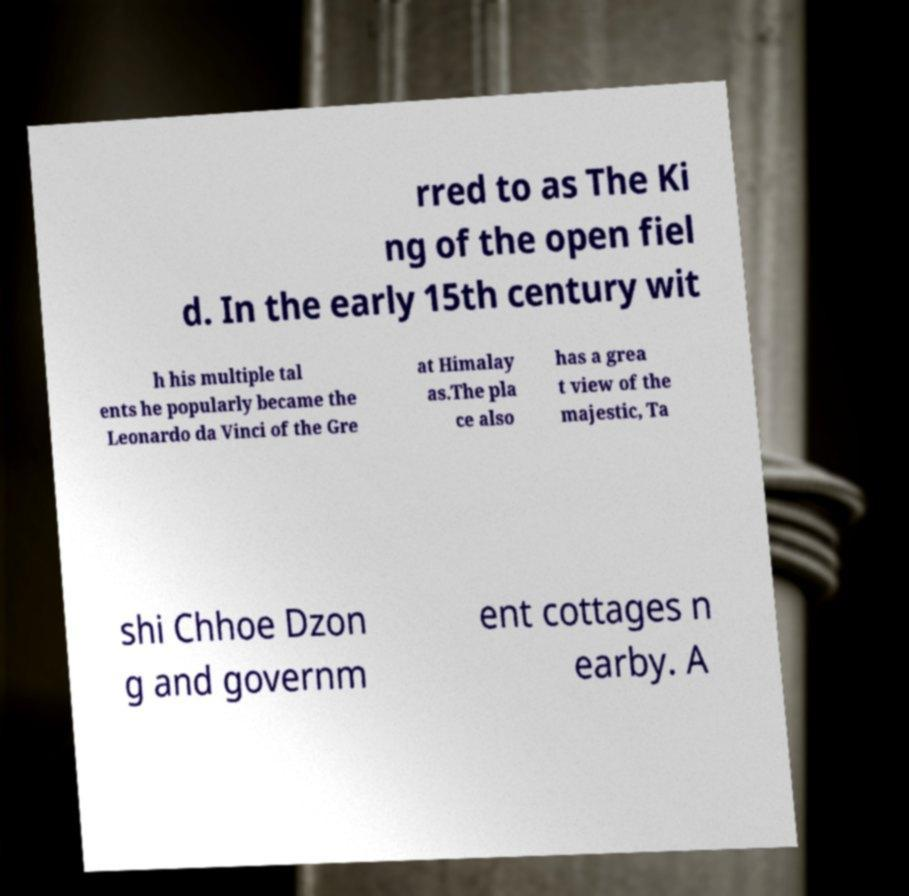Can you read and provide the text displayed in the image?This photo seems to have some interesting text. Can you extract and type it out for me? rred to as The Ki ng of the open fiel d. In the early 15th century wit h his multiple tal ents he popularly became the Leonardo da Vinci of the Gre at Himalay as.The pla ce also has a grea t view of the majestic, Ta shi Chhoe Dzon g and governm ent cottages n earby. A 